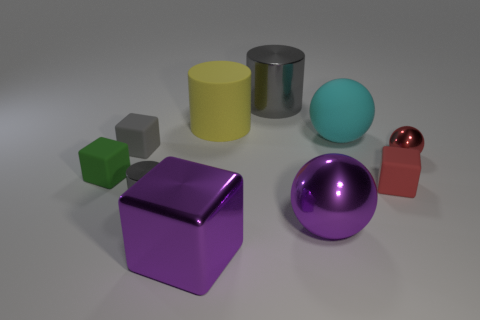What can you deduce about the lighting in this scene? The lighting in the scene seems to be soft and diffused, likely from a source above and possibly out of view. There are gentle shadows under the objects, and their surfaces have soft reflections, which indicate the light is not overly harsh. The lighting setup aims to minimize hard shadows while still providing enough contrast to clearly define the forms of the objects. 